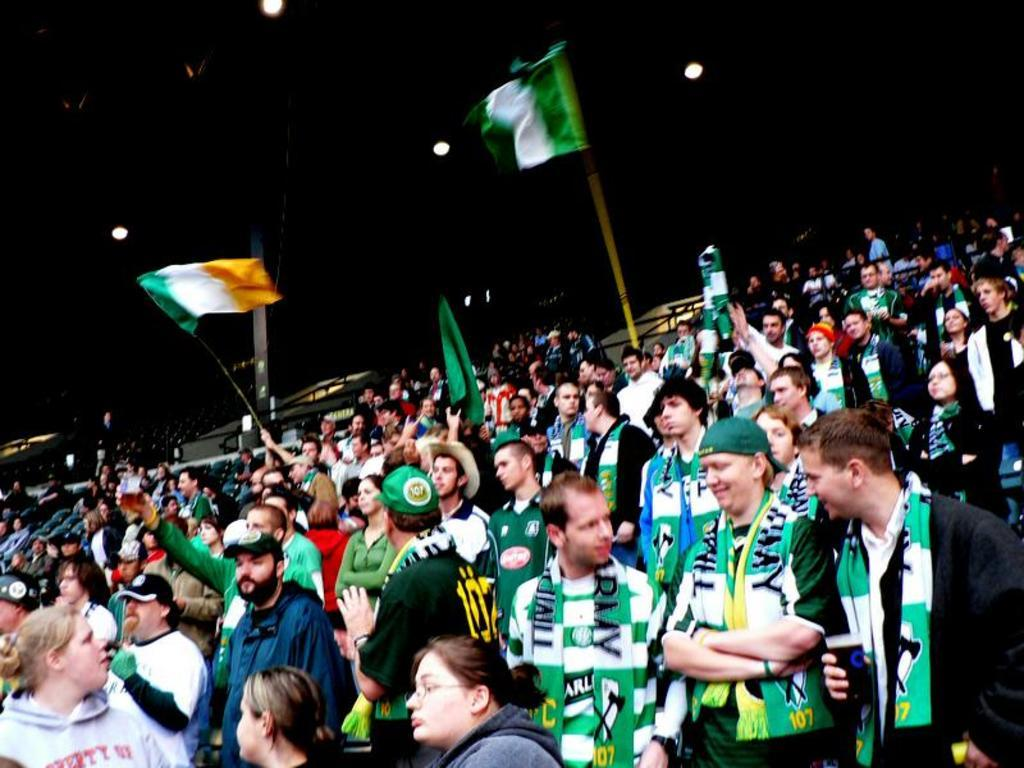What type of location is depicted in the image? The image appears to be taken in a stadium. What are the people in the image doing? The people are standing and holding flags. What can be seen in the sky in the image? The sky is visible at the top of the image. What type of oatmeal is being served to the horses in the image? There are no horses or oatmeal present in the image; it features a stadium with people holding flags. 